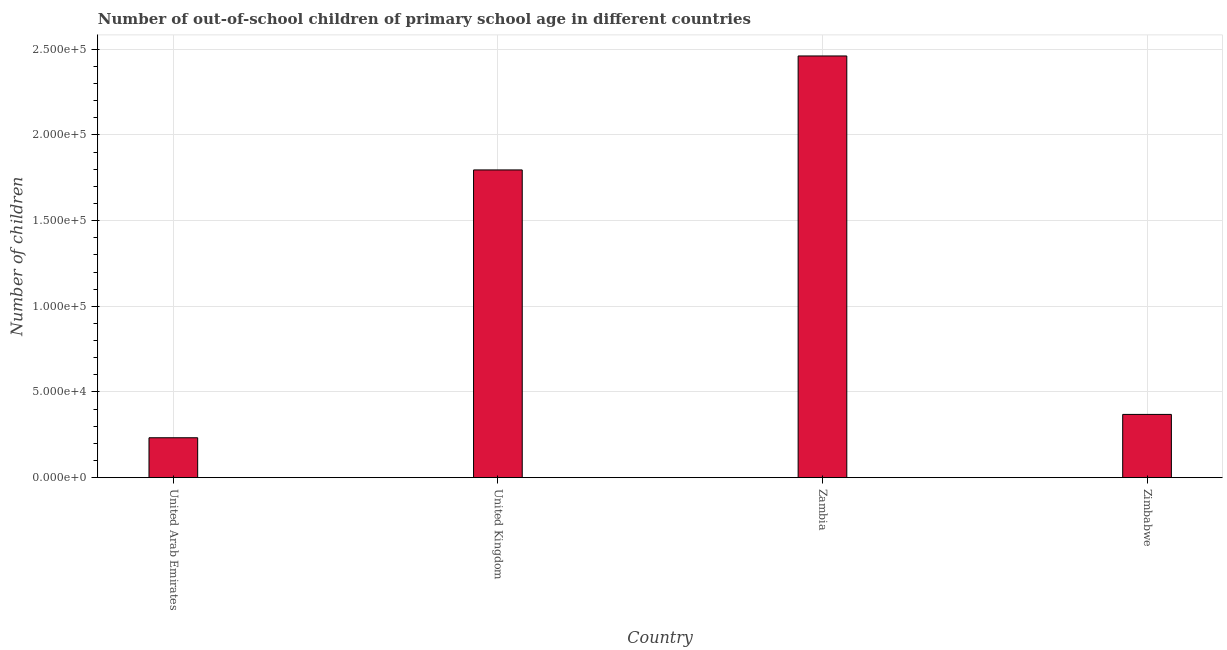Does the graph contain grids?
Offer a terse response. Yes. What is the title of the graph?
Offer a very short reply. Number of out-of-school children of primary school age in different countries. What is the label or title of the Y-axis?
Your answer should be very brief. Number of children. What is the number of out-of-school children in United Kingdom?
Make the answer very short. 1.80e+05. Across all countries, what is the maximum number of out-of-school children?
Your answer should be compact. 2.46e+05. Across all countries, what is the minimum number of out-of-school children?
Offer a very short reply. 2.33e+04. In which country was the number of out-of-school children maximum?
Provide a short and direct response. Zambia. In which country was the number of out-of-school children minimum?
Offer a very short reply. United Arab Emirates. What is the sum of the number of out-of-school children?
Keep it short and to the point. 4.86e+05. What is the difference between the number of out-of-school children in United Arab Emirates and Zimbabwe?
Make the answer very short. -1.36e+04. What is the average number of out-of-school children per country?
Provide a succinct answer. 1.21e+05. What is the median number of out-of-school children?
Give a very brief answer. 1.08e+05. In how many countries, is the number of out-of-school children greater than 220000 ?
Offer a very short reply. 1. What is the ratio of the number of out-of-school children in United Arab Emirates to that in Zambia?
Offer a terse response. 0.1. What is the difference between the highest and the second highest number of out-of-school children?
Offer a terse response. 6.65e+04. What is the difference between the highest and the lowest number of out-of-school children?
Give a very brief answer. 2.23e+05. How many bars are there?
Keep it short and to the point. 4. Are all the bars in the graph horizontal?
Offer a terse response. No. Are the values on the major ticks of Y-axis written in scientific E-notation?
Give a very brief answer. Yes. What is the Number of children of United Arab Emirates?
Provide a succinct answer. 2.33e+04. What is the Number of children of United Kingdom?
Offer a very short reply. 1.80e+05. What is the Number of children of Zambia?
Provide a succinct answer. 2.46e+05. What is the Number of children in Zimbabwe?
Your answer should be very brief. 3.69e+04. What is the difference between the Number of children in United Arab Emirates and United Kingdom?
Your answer should be compact. -1.56e+05. What is the difference between the Number of children in United Arab Emirates and Zambia?
Your answer should be compact. -2.23e+05. What is the difference between the Number of children in United Arab Emirates and Zimbabwe?
Your answer should be very brief. -1.36e+04. What is the difference between the Number of children in United Kingdom and Zambia?
Keep it short and to the point. -6.65e+04. What is the difference between the Number of children in United Kingdom and Zimbabwe?
Keep it short and to the point. 1.43e+05. What is the difference between the Number of children in Zambia and Zimbabwe?
Your response must be concise. 2.09e+05. What is the ratio of the Number of children in United Arab Emirates to that in United Kingdom?
Provide a succinct answer. 0.13. What is the ratio of the Number of children in United Arab Emirates to that in Zambia?
Provide a succinct answer. 0.1. What is the ratio of the Number of children in United Arab Emirates to that in Zimbabwe?
Give a very brief answer. 0.63. What is the ratio of the Number of children in United Kingdom to that in Zambia?
Your answer should be compact. 0.73. What is the ratio of the Number of children in United Kingdom to that in Zimbabwe?
Offer a terse response. 4.87. What is the ratio of the Number of children in Zambia to that in Zimbabwe?
Your answer should be very brief. 6.67. 